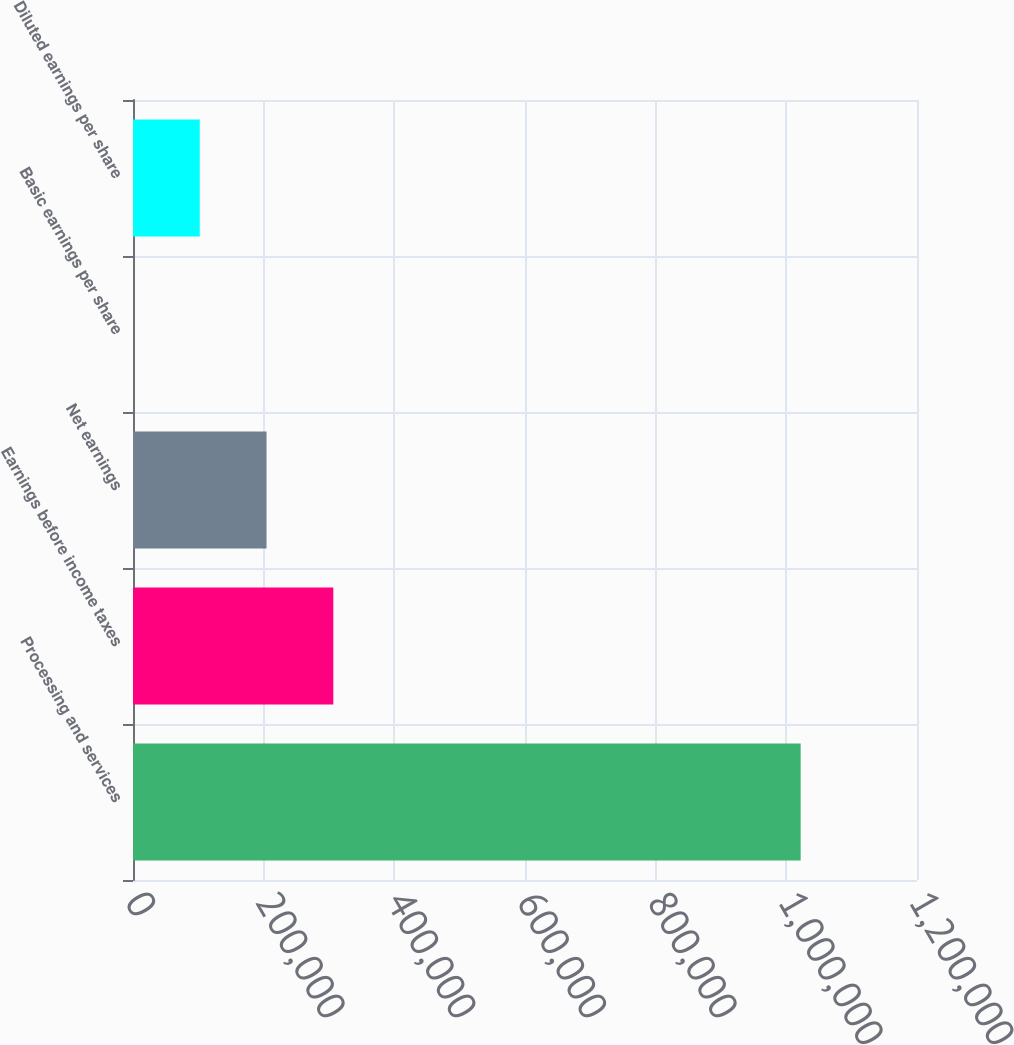Convert chart. <chart><loc_0><loc_0><loc_500><loc_500><bar_chart><fcel>Processing and services<fcel>Earnings before income taxes<fcel>Net earnings<fcel>Basic earnings per share<fcel>Diluted earnings per share<nl><fcel>1.02195e+06<fcel>306584<fcel>204389<fcel>0.34<fcel>102195<nl></chart> 